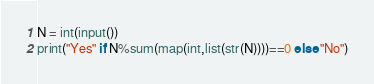Convert code to text. <code><loc_0><loc_0><loc_500><loc_500><_Python_>N = int(input())
print("Yes" if N%sum(map(int,list(str(N))))==0 else "No")</code> 